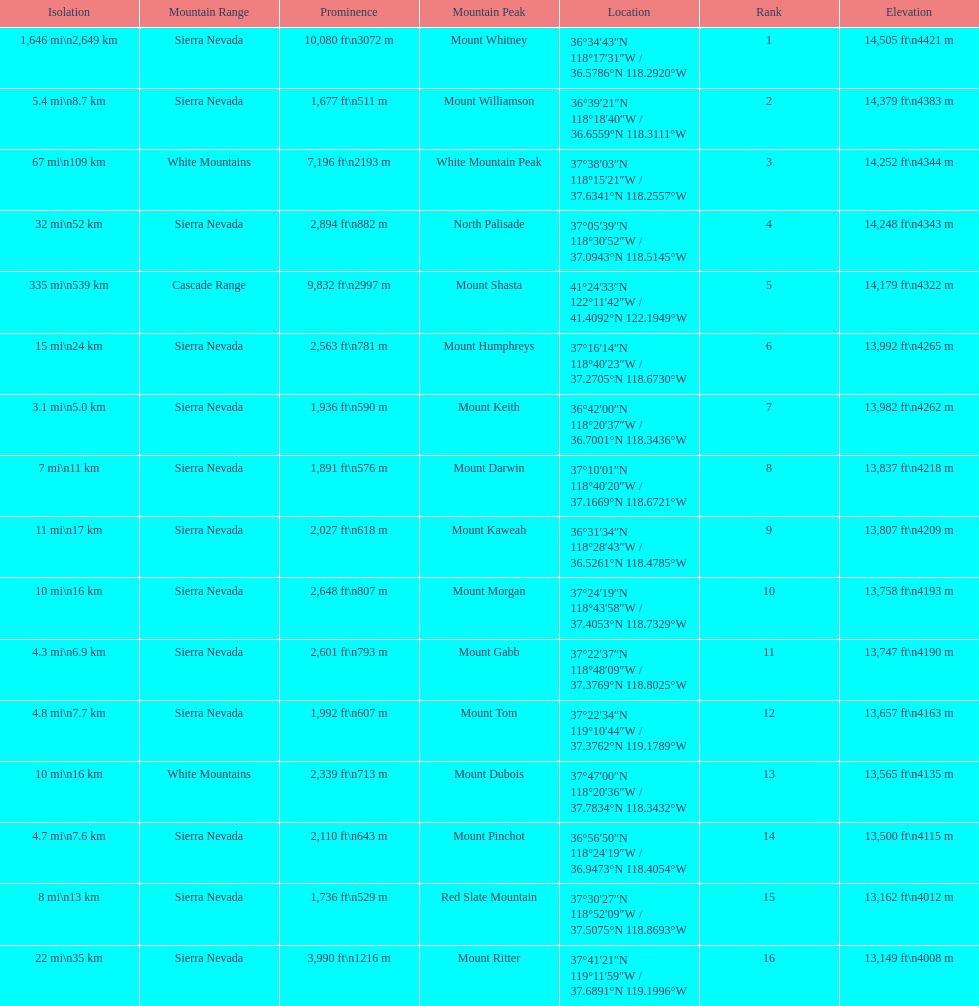What is the total elevation (in ft) of mount whitney? 14,505 ft. 